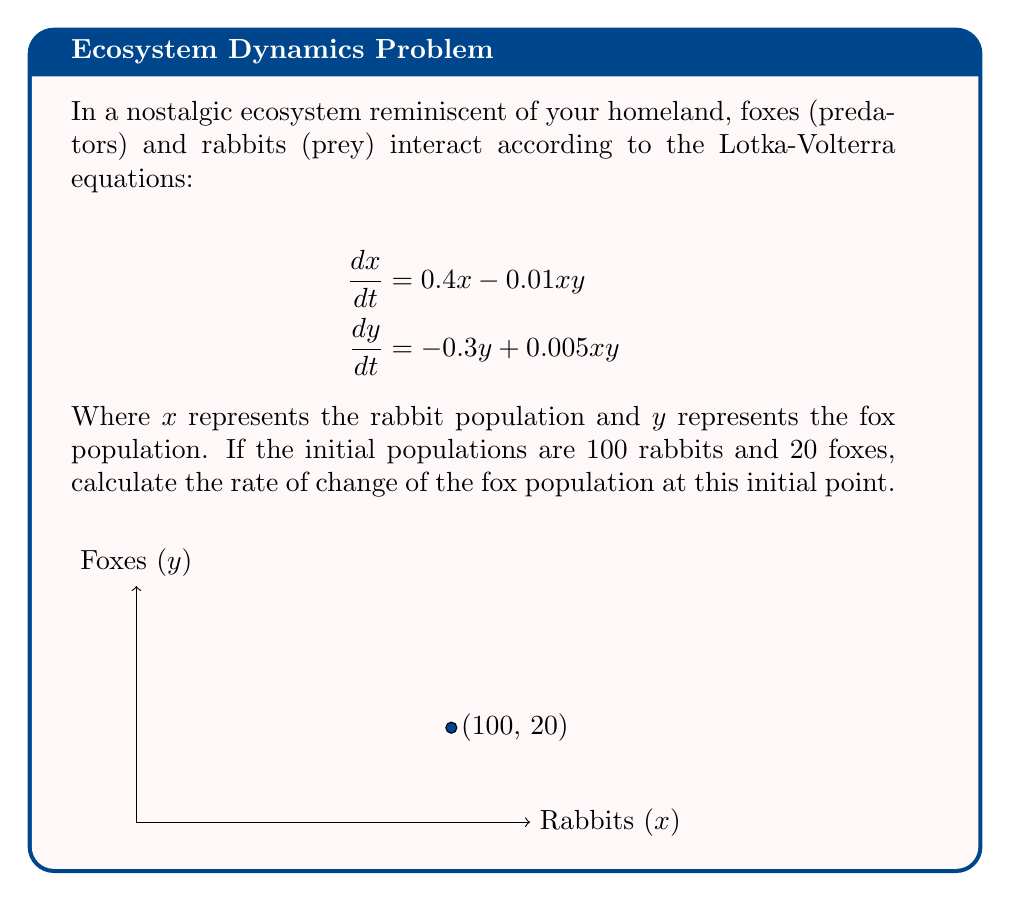Help me with this question. To solve this problem, we'll follow these steps:

1) We are given the Lotka-Volterra equations:
   $$\frac{dx}{dt} = 0.4x - 0.01xy$$
   $$\frac{dy}{dt} = -0.3y + 0.005xy$$

2) We're interested in the rate of change of the fox population, which is represented by $\frac{dy}{dt}$.

3) We're given the initial populations:
   $x = 100$ (rabbits)
   $y = 20$ (foxes)

4) To find the rate of change of the fox population, we need to substitute these values into the equation for $\frac{dy}{dt}$:

   $$\frac{dy}{dt} = -0.3y + 0.005xy$$

5) Substituting the values:
   $$\frac{dy}{dt} = -0.3(20) + 0.005(100)(20)$$

6) Let's calculate each term:
   $-0.3(20) = -6$
   $0.005(100)(20) = 10$

7) Now, we can add these terms:
   $$\frac{dy}{dt} = -6 + 10 = 4$$

Therefore, at the initial point, the rate of change of the fox population is 4 foxes per time unit.
Answer: 4 foxes per time unit 